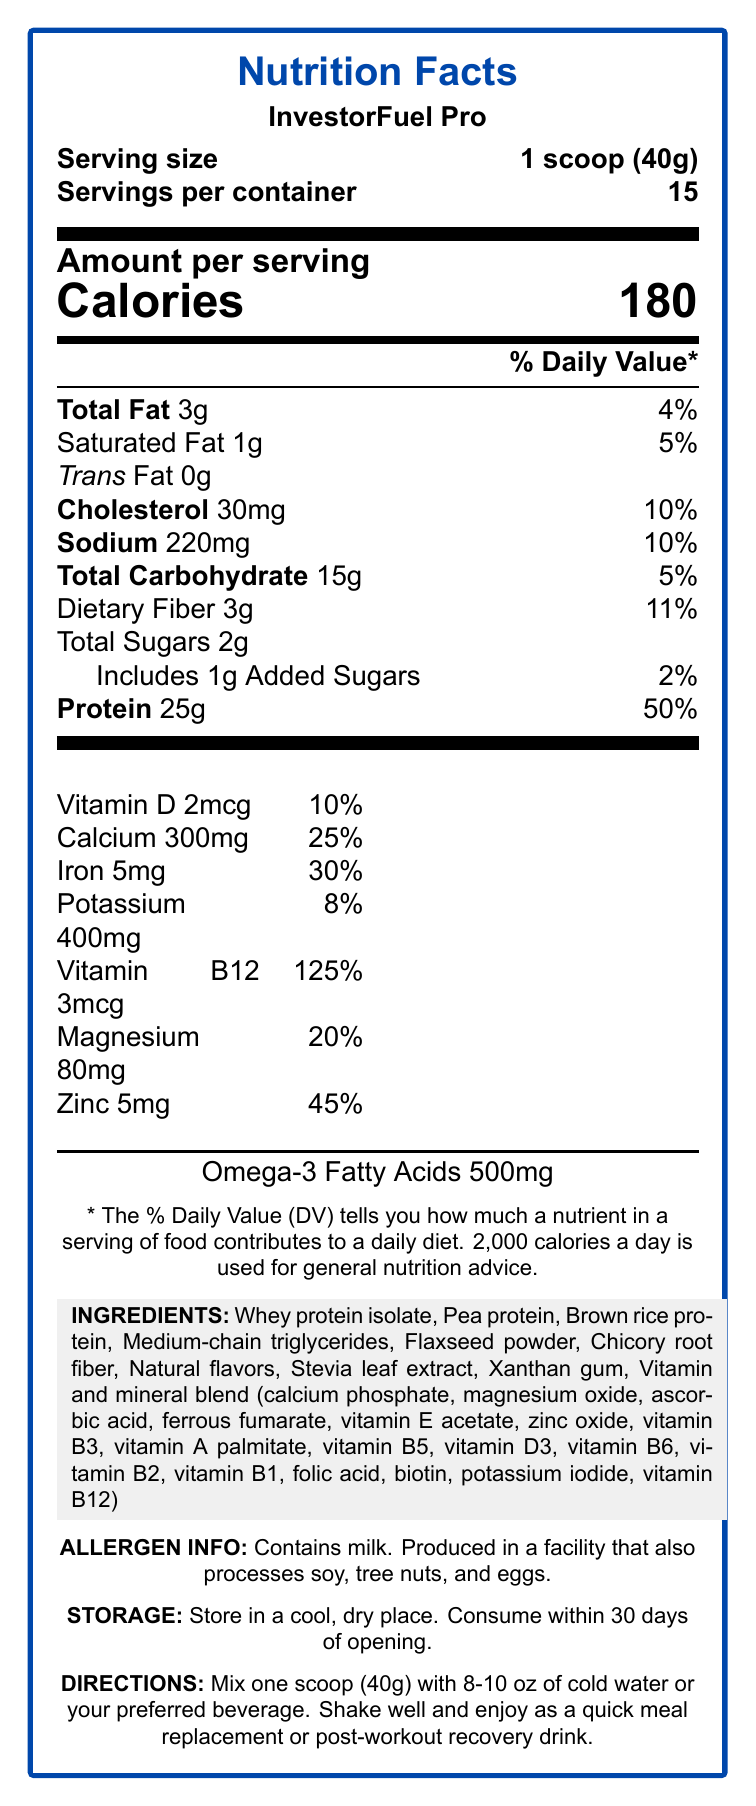What is the serving size of InvestorFuel Pro? The document clearly states that the serving size is "1 scoop (40g)".
Answer: 1 scoop (40g) How many servings are there per container of InvestorFuel Pro? The document indicates that there are 15 servings per container.
Answer: 15 How much protein is there per serving? The document specifies that each serving contains 25g of protein.
Answer: 25g What percentage of the daily value of Vitamin B12 does one serving provide? The document shows that one serving provides 125% of the daily value of Vitamin B12.
Answer: 125% Does InvestorFuel Pro contain any trans fat? The document states that the amount of trans fat is 0g.
Answer: No Which of the following minerals is present in the highest amount per serving of InvestorFuel Pro?
A. Calcium  
B. Iron  
C. Potassium  
D. Magnesium The document indicates that Calcium is present at 300mg per serving, which is higher than the amounts of iron (5mg), potassium (400mg), and magnesium (80mg).
Answer: A What is the total number of calories per serving? 
1. 150  
2. 180  
3. 200  
4. 250 The document clearly states that there are 180 calories per serving.
Answer: 2 Is InvestorFuel Pro marketed as a low-sugar product? The marketing claims in the document indicate that InvestorFuel Pro is marketed as low in sugar.
Answer: Yes Can you summarize the main points of the nutrition label for InvestorFuel Pro? The document provides detailed information regarding the nutritional content, serving size, and various health benefits of InvestorFuel Pro, as well as specific storage instructions and allergen information.
Answer: InvestorFuel Pro is a high-protein meal replacement shake with 180 calories per serving, providing several key nutrients and vitamins including 25g of protein, 3g of total fat, and a range of vitamins and minerals. It is designed for busy investors and offers low sugar content with added benefits such as Omega-3 fatty acids. The shake contains milk and should be stored in a cool, dry place. What is the price of InvestorFuel Pro? The document does not provide any information regarding the price of InvestorFuel Pro.
Answer: Cannot be determined 